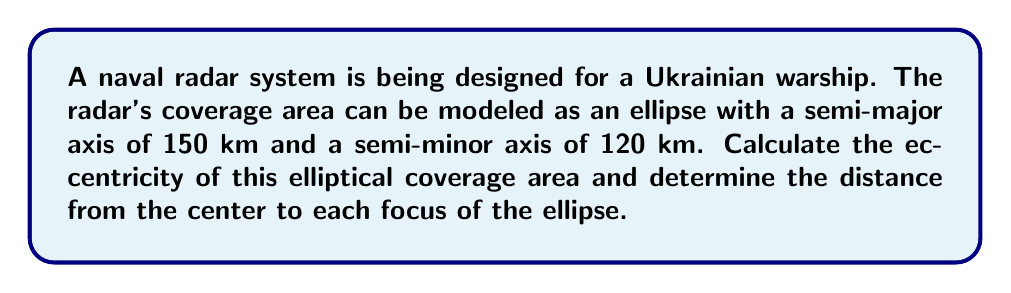Can you answer this question? Let's approach this step-by-step:

1) The eccentricity (e) of an ellipse is given by the formula:

   $$e = \sqrt{1 - \frac{b^2}{a^2}}$$

   where $a$ is the semi-major axis and $b$ is the semi-minor axis.

2) We are given:
   $a = 150$ km
   $b = 120$ km

3) Substituting these values into the eccentricity formula:

   $$e = \sqrt{1 - \frac{120^2}{150^2}}$$

4) Simplify:
   $$e = \sqrt{1 - \frac{14400}{22500}}$$
   $$e = \sqrt{1 - 0.64}$$
   $$e = \sqrt{0.36}$$
   $$e = 0.6$$

5) Now, to find the distance from the center to each focus, we use the formula:

   $$c = ae$$

   where $c$ is the distance from the center to a focus.

6) Substituting our values:

   $$c = 150 \times 0.6 = 90$$ km

Therefore, the distance from the center to each focus is 90 km.

[asy]
unitsize(1cm);
pair A=(-5,0), B=(5,0), C=(0,4), D=(0,-4), F1=(-3,0), F2=(3,0);
draw(ellipse(A,B,C,D));
dot(F1); dot(F2);
label("F1",F1,SW);
label("F2",F2,SE);
label("150 km",(-2.5,3.5),N);
label("120 km",(5.2,0),E);
draw((0,0)--(5,0),Arrow);
draw((0,0)--(0,4),Arrow);
[/asy]
Answer: Eccentricity: 0.6; Distance to each focus: 90 km 